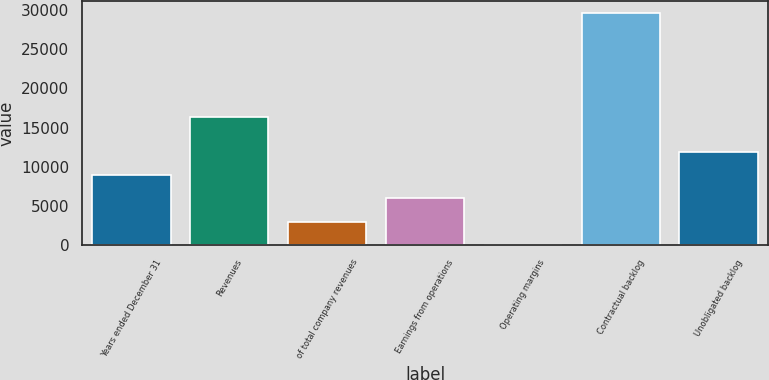Convert chart. <chart><loc_0><loc_0><loc_500><loc_500><bar_chart><fcel>Years ended December 31<fcel>Revenues<fcel>of total company revenues<fcel>Earnings from operations<fcel>Operating margins<fcel>Contractual backlog<fcel>Unobligated backlog<nl><fcel>8908.92<fcel>16384<fcel>2976.04<fcel>5942.48<fcel>9.6<fcel>29674<fcel>11875.4<nl></chart> 